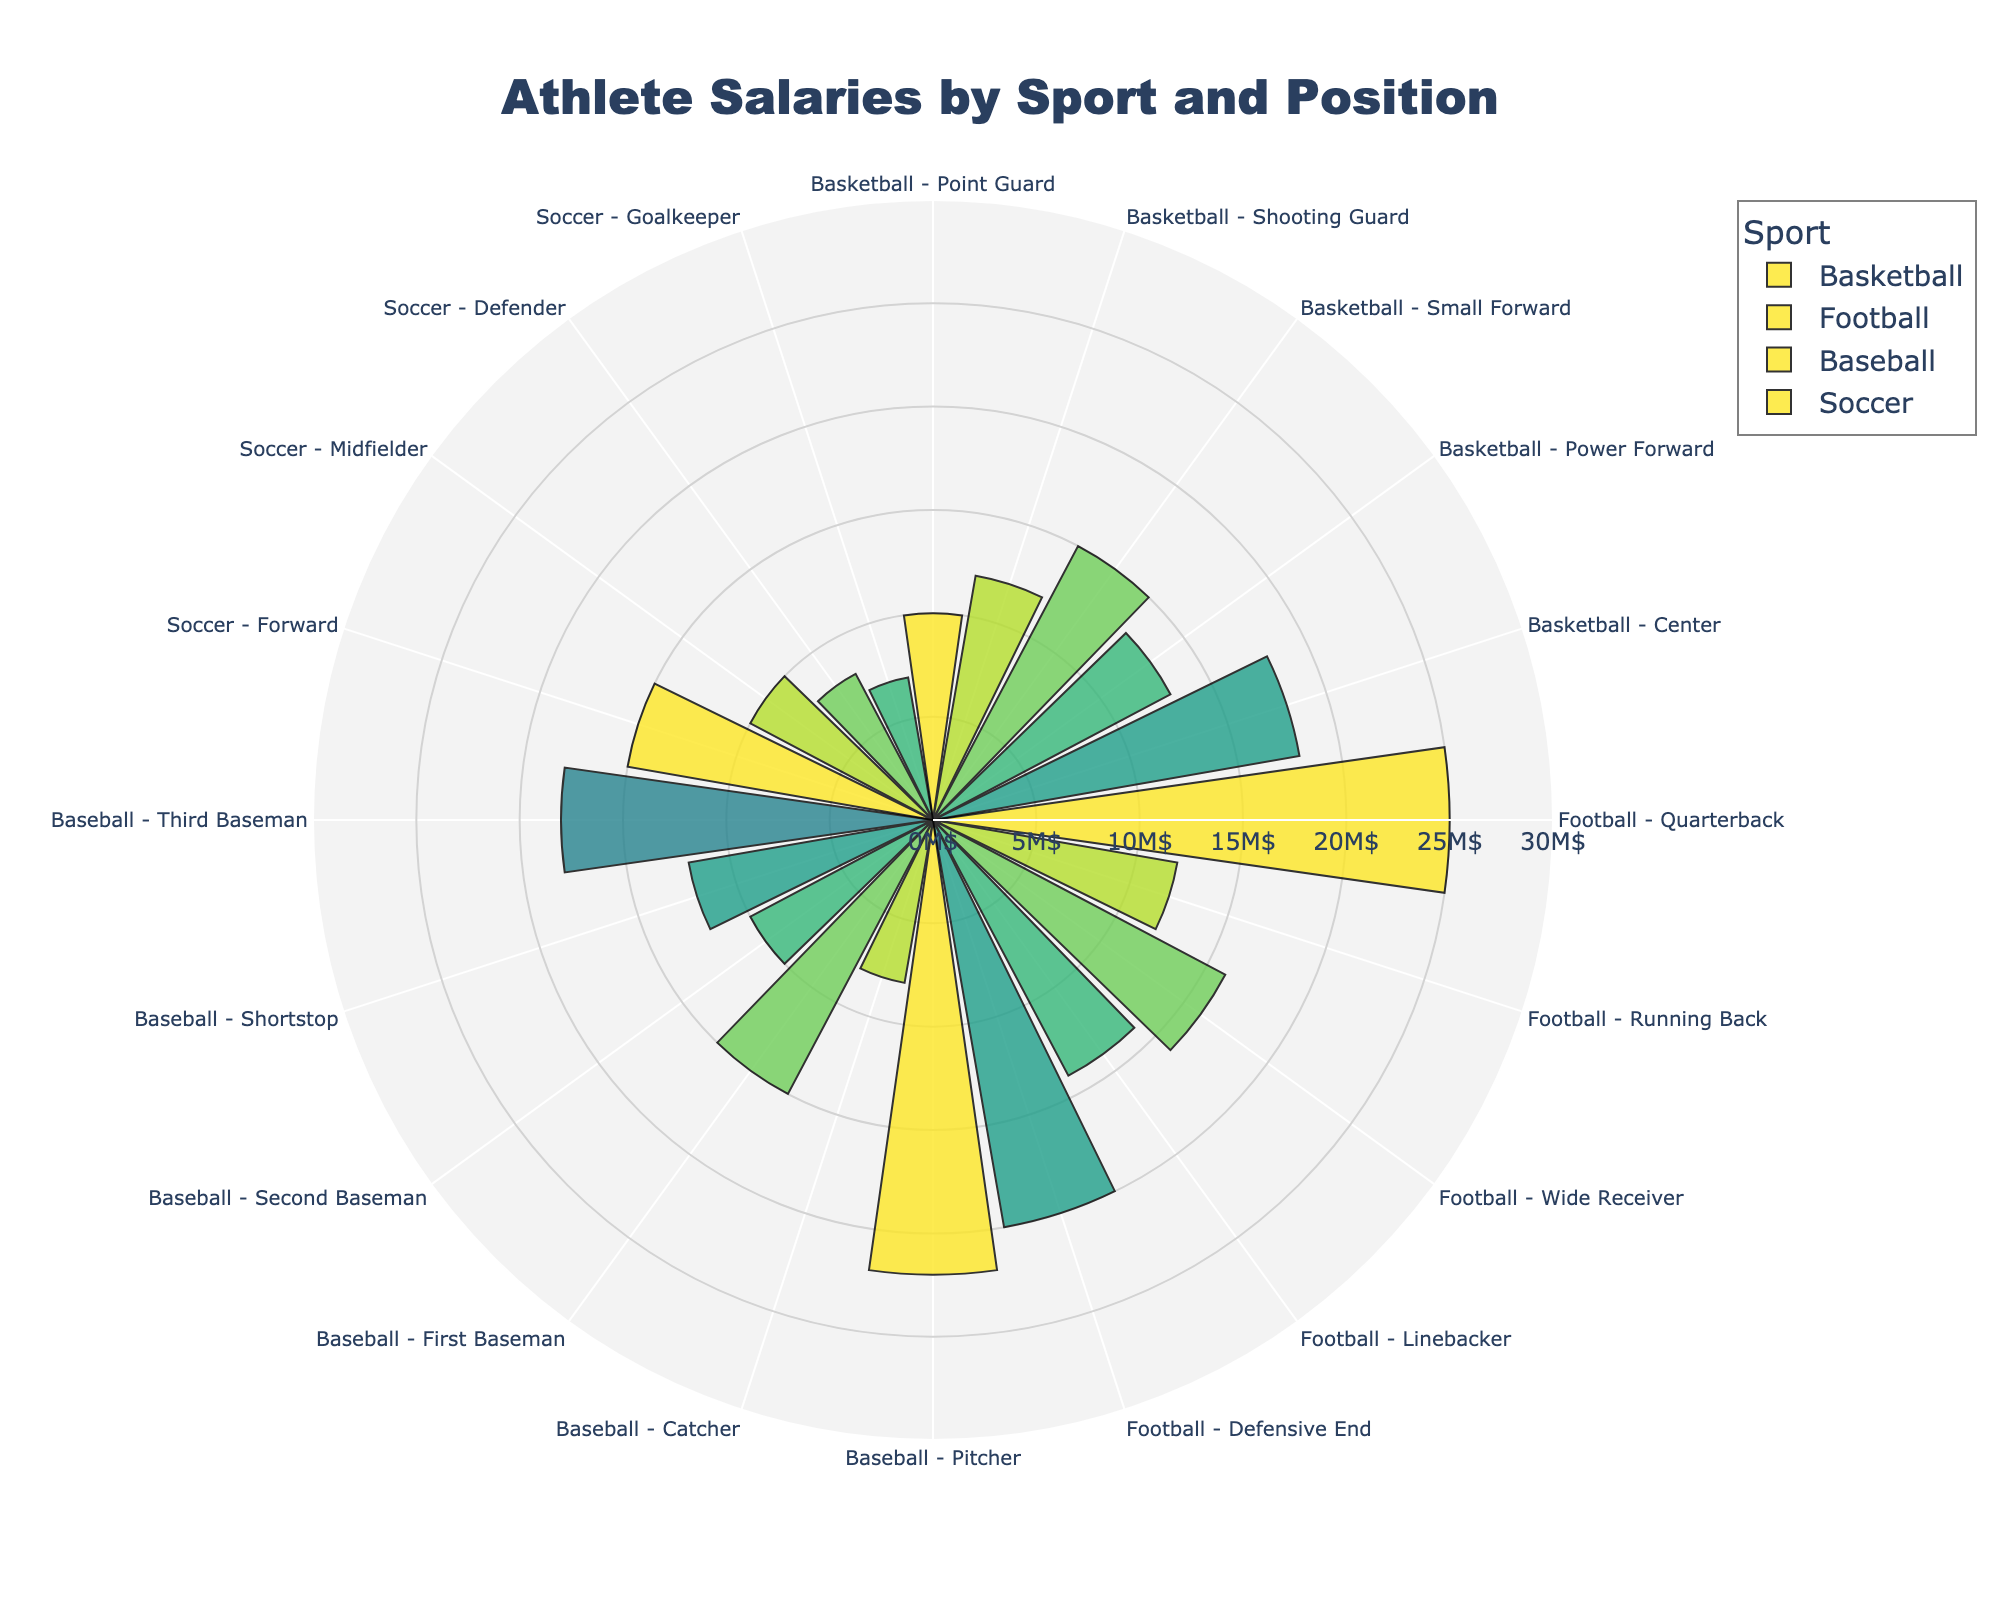What's the title of the figure? The title of a chart is usually placed at the top and states what the chart is about. In this case, it shows us the salaries in million dollars by sport and position.
Answer: Athlete Salaries by Sport and Position How many positions are there in Basketball? To find the number of positions in Basketball, look at the segments related to Basketball in the polar chart. Each segment represents a position. Count these segments.
Answer: 5 Which sport has the highest average salary and what is the position? Identify the segment with the longest radial distance. Look at the details in this segment to find the sport and position associated with the highest average salary.
Answer: Football, Quarterback What is the average salary difference between a Basketball Center and a Baseball Pitcher? Determine the radial distance for both Basketball Center and Baseball Pitcher from the chart. Subtract the smaller radial value from the larger one to find the difference.
Answer: 4M$ How does the average salary of a Soccer Midfielder compare to that of a Baseball Second Baseman? Find the segments for Soccer Midfielder and Baseball Second Baseman. Compare the radial distances to determine which is longer.
Answer: They are equal What is the combined average salary of all positions in Soccer? Identify all the positions in Soccer and note their respective average salaries. Add these salaries together to find the total.
Answer: 40M$ Which sport has the least variability in average salaries across positions? Determine the range of salaries for each sport by identifying the highest and lowest salaries within each sport. The sport with the smallest difference has the least variability.
Answer: Soccer Which position in Football has the highest average salary? Focus on the segments related to Football. Identify the segment with the longest radial distance to find the position with the highest average salary.
Answer: Quarterback Compare the average salary of a Baseball Catcher to a Soccer Defender. Which is higher and by how much? Identify the segments for both Baseball Catcher and Soccer Defender. Find their radial distances and subtract the shorter from the longer.
Answer: Baseball Catcher, 1M$ What is the range of average salaries for positions in Baseball? Determine the highest and lowest average salaries for positions in Baseball by looking at their radial distances. Subtract the smallest value from the largest to find the range.
Answer: 14M$ 